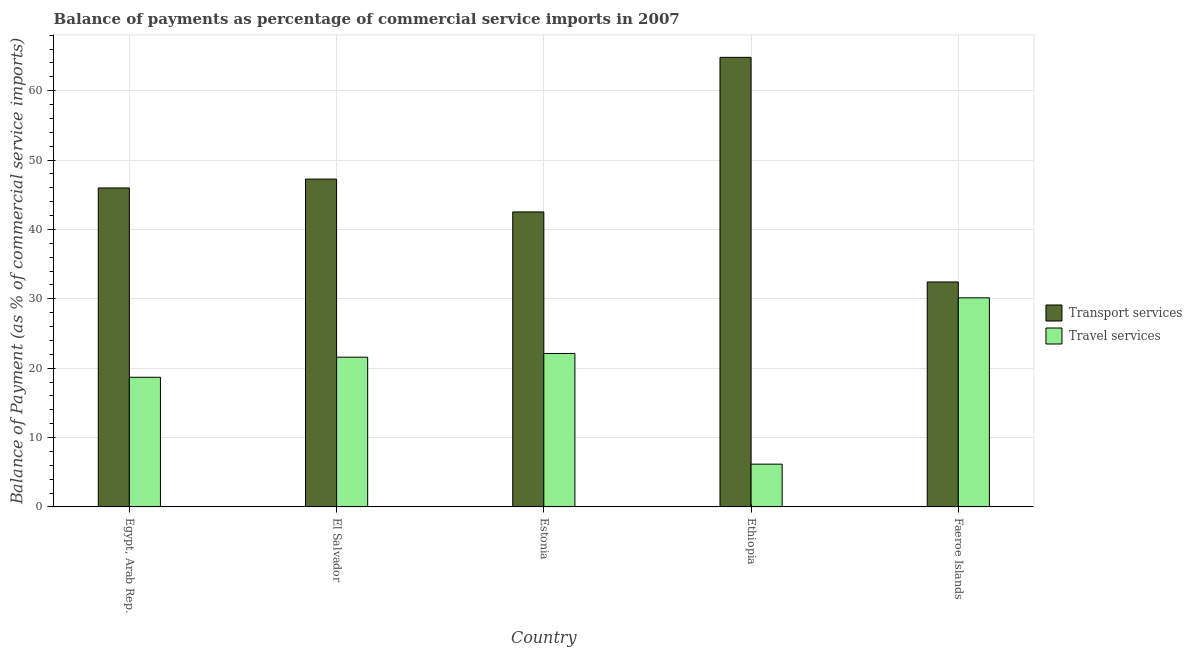Are the number of bars per tick equal to the number of legend labels?
Your response must be concise. Yes. Are the number of bars on each tick of the X-axis equal?
Give a very brief answer. Yes. How many bars are there on the 1st tick from the right?
Provide a short and direct response. 2. What is the label of the 1st group of bars from the left?
Your answer should be very brief. Egypt, Arab Rep. In how many cases, is the number of bars for a given country not equal to the number of legend labels?
Provide a short and direct response. 0. What is the balance of payments of travel services in Estonia?
Your answer should be very brief. 22.12. Across all countries, what is the maximum balance of payments of transport services?
Keep it short and to the point. 64.8. Across all countries, what is the minimum balance of payments of travel services?
Your response must be concise. 6.17. In which country was the balance of payments of travel services maximum?
Provide a succinct answer. Faeroe Islands. In which country was the balance of payments of transport services minimum?
Give a very brief answer. Faeroe Islands. What is the total balance of payments of travel services in the graph?
Provide a short and direct response. 98.7. What is the difference between the balance of payments of transport services in Egypt, Arab Rep. and that in Ethiopia?
Your answer should be very brief. -18.82. What is the difference between the balance of payments of travel services in Estonia and the balance of payments of transport services in Ethiopia?
Offer a terse response. -42.68. What is the average balance of payments of transport services per country?
Your response must be concise. 46.6. What is the difference between the balance of payments of transport services and balance of payments of travel services in Ethiopia?
Provide a short and direct response. 58.63. In how many countries, is the balance of payments of travel services greater than 16 %?
Give a very brief answer. 4. What is the ratio of the balance of payments of travel services in El Salvador to that in Ethiopia?
Offer a terse response. 3.5. What is the difference between the highest and the second highest balance of payments of transport services?
Keep it short and to the point. 17.55. What is the difference between the highest and the lowest balance of payments of travel services?
Your response must be concise. 23.97. In how many countries, is the balance of payments of travel services greater than the average balance of payments of travel services taken over all countries?
Provide a succinct answer. 3. Is the sum of the balance of payments of travel services in Egypt, Arab Rep. and El Salvador greater than the maximum balance of payments of transport services across all countries?
Provide a succinct answer. No. What does the 2nd bar from the left in Ethiopia represents?
Provide a succinct answer. Travel services. What does the 1st bar from the right in Ethiopia represents?
Your response must be concise. Travel services. How many countries are there in the graph?
Offer a very short reply. 5. What is the difference between two consecutive major ticks on the Y-axis?
Offer a terse response. 10. Are the values on the major ticks of Y-axis written in scientific E-notation?
Offer a terse response. No. Does the graph contain grids?
Make the answer very short. Yes. Where does the legend appear in the graph?
Make the answer very short. Center right. How many legend labels are there?
Offer a very short reply. 2. What is the title of the graph?
Offer a terse response. Balance of payments as percentage of commercial service imports in 2007. Does "Non-pregnant women" appear as one of the legend labels in the graph?
Your answer should be compact. No. What is the label or title of the Y-axis?
Your answer should be very brief. Balance of Payment (as % of commercial service imports). What is the Balance of Payment (as % of commercial service imports) of Transport services in Egypt, Arab Rep.?
Offer a terse response. 45.98. What is the Balance of Payment (as % of commercial service imports) of Travel services in Egypt, Arab Rep.?
Give a very brief answer. 18.69. What is the Balance of Payment (as % of commercial service imports) of Transport services in El Salvador?
Provide a short and direct response. 47.25. What is the Balance of Payment (as % of commercial service imports) in Travel services in El Salvador?
Give a very brief answer. 21.59. What is the Balance of Payment (as % of commercial service imports) of Transport services in Estonia?
Your answer should be very brief. 42.52. What is the Balance of Payment (as % of commercial service imports) of Travel services in Estonia?
Keep it short and to the point. 22.12. What is the Balance of Payment (as % of commercial service imports) of Transport services in Ethiopia?
Your answer should be very brief. 64.8. What is the Balance of Payment (as % of commercial service imports) in Travel services in Ethiopia?
Your answer should be compact. 6.17. What is the Balance of Payment (as % of commercial service imports) in Transport services in Faeroe Islands?
Provide a succinct answer. 32.43. What is the Balance of Payment (as % of commercial service imports) of Travel services in Faeroe Islands?
Offer a terse response. 30.14. Across all countries, what is the maximum Balance of Payment (as % of commercial service imports) in Transport services?
Offer a terse response. 64.8. Across all countries, what is the maximum Balance of Payment (as % of commercial service imports) of Travel services?
Offer a very short reply. 30.14. Across all countries, what is the minimum Balance of Payment (as % of commercial service imports) of Transport services?
Your answer should be compact. 32.43. Across all countries, what is the minimum Balance of Payment (as % of commercial service imports) in Travel services?
Your answer should be compact. 6.17. What is the total Balance of Payment (as % of commercial service imports) in Transport services in the graph?
Give a very brief answer. 232.98. What is the total Balance of Payment (as % of commercial service imports) of Travel services in the graph?
Offer a very short reply. 98.7. What is the difference between the Balance of Payment (as % of commercial service imports) of Transport services in Egypt, Arab Rep. and that in El Salvador?
Make the answer very short. -1.28. What is the difference between the Balance of Payment (as % of commercial service imports) of Travel services in Egypt, Arab Rep. and that in El Salvador?
Your response must be concise. -2.9. What is the difference between the Balance of Payment (as % of commercial service imports) of Transport services in Egypt, Arab Rep. and that in Estonia?
Make the answer very short. 3.46. What is the difference between the Balance of Payment (as % of commercial service imports) of Travel services in Egypt, Arab Rep. and that in Estonia?
Your response must be concise. -3.43. What is the difference between the Balance of Payment (as % of commercial service imports) in Transport services in Egypt, Arab Rep. and that in Ethiopia?
Provide a short and direct response. -18.82. What is the difference between the Balance of Payment (as % of commercial service imports) of Travel services in Egypt, Arab Rep. and that in Ethiopia?
Your response must be concise. 12.52. What is the difference between the Balance of Payment (as % of commercial service imports) of Transport services in Egypt, Arab Rep. and that in Faeroe Islands?
Your answer should be compact. 13.55. What is the difference between the Balance of Payment (as % of commercial service imports) of Travel services in Egypt, Arab Rep. and that in Faeroe Islands?
Your response must be concise. -11.45. What is the difference between the Balance of Payment (as % of commercial service imports) in Transport services in El Salvador and that in Estonia?
Offer a terse response. 4.73. What is the difference between the Balance of Payment (as % of commercial service imports) in Travel services in El Salvador and that in Estonia?
Provide a short and direct response. -0.53. What is the difference between the Balance of Payment (as % of commercial service imports) of Transport services in El Salvador and that in Ethiopia?
Your answer should be compact. -17.55. What is the difference between the Balance of Payment (as % of commercial service imports) of Travel services in El Salvador and that in Ethiopia?
Your answer should be very brief. 15.42. What is the difference between the Balance of Payment (as % of commercial service imports) in Transport services in El Salvador and that in Faeroe Islands?
Make the answer very short. 14.83. What is the difference between the Balance of Payment (as % of commercial service imports) of Travel services in El Salvador and that in Faeroe Islands?
Provide a short and direct response. -8.56. What is the difference between the Balance of Payment (as % of commercial service imports) of Transport services in Estonia and that in Ethiopia?
Your response must be concise. -22.28. What is the difference between the Balance of Payment (as % of commercial service imports) in Travel services in Estonia and that in Ethiopia?
Make the answer very short. 15.95. What is the difference between the Balance of Payment (as % of commercial service imports) of Transport services in Estonia and that in Faeroe Islands?
Ensure brevity in your answer.  10.09. What is the difference between the Balance of Payment (as % of commercial service imports) in Travel services in Estonia and that in Faeroe Islands?
Provide a short and direct response. -8.02. What is the difference between the Balance of Payment (as % of commercial service imports) of Transport services in Ethiopia and that in Faeroe Islands?
Your answer should be very brief. 32.38. What is the difference between the Balance of Payment (as % of commercial service imports) of Travel services in Ethiopia and that in Faeroe Islands?
Make the answer very short. -23.97. What is the difference between the Balance of Payment (as % of commercial service imports) of Transport services in Egypt, Arab Rep. and the Balance of Payment (as % of commercial service imports) of Travel services in El Salvador?
Give a very brief answer. 24.39. What is the difference between the Balance of Payment (as % of commercial service imports) in Transport services in Egypt, Arab Rep. and the Balance of Payment (as % of commercial service imports) in Travel services in Estonia?
Offer a very short reply. 23.86. What is the difference between the Balance of Payment (as % of commercial service imports) in Transport services in Egypt, Arab Rep. and the Balance of Payment (as % of commercial service imports) in Travel services in Ethiopia?
Your answer should be compact. 39.81. What is the difference between the Balance of Payment (as % of commercial service imports) of Transport services in Egypt, Arab Rep. and the Balance of Payment (as % of commercial service imports) of Travel services in Faeroe Islands?
Offer a terse response. 15.84. What is the difference between the Balance of Payment (as % of commercial service imports) in Transport services in El Salvador and the Balance of Payment (as % of commercial service imports) in Travel services in Estonia?
Offer a very short reply. 25.13. What is the difference between the Balance of Payment (as % of commercial service imports) in Transport services in El Salvador and the Balance of Payment (as % of commercial service imports) in Travel services in Ethiopia?
Provide a short and direct response. 41.09. What is the difference between the Balance of Payment (as % of commercial service imports) in Transport services in El Salvador and the Balance of Payment (as % of commercial service imports) in Travel services in Faeroe Islands?
Provide a short and direct response. 17.11. What is the difference between the Balance of Payment (as % of commercial service imports) in Transport services in Estonia and the Balance of Payment (as % of commercial service imports) in Travel services in Ethiopia?
Provide a short and direct response. 36.35. What is the difference between the Balance of Payment (as % of commercial service imports) in Transport services in Estonia and the Balance of Payment (as % of commercial service imports) in Travel services in Faeroe Islands?
Ensure brevity in your answer.  12.38. What is the difference between the Balance of Payment (as % of commercial service imports) in Transport services in Ethiopia and the Balance of Payment (as % of commercial service imports) in Travel services in Faeroe Islands?
Ensure brevity in your answer.  34.66. What is the average Balance of Payment (as % of commercial service imports) in Transport services per country?
Make the answer very short. 46.6. What is the average Balance of Payment (as % of commercial service imports) of Travel services per country?
Your response must be concise. 19.74. What is the difference between the Balance of Payment (as % of commercial service imports) of Transport services and Balance of Payment (as % of commercial service imports) of Travel services in Egypt, Arab Rep.?
Offer a very short reply. 27.29. What is the difference between the Balance of Payment (as % of commercial service imports) of Transport services and Balance of Payment (as % of commercial service imports) of Travel services in El Salvador?
Your response must be concise. 25.67. What is the difference between the Balance of Payment (as % of commercial service imports) in Transport services and Balance of Payment (as % of commercial service imports) in Travel services in Estonia?
Provide a succinct answer. 20.4. What is the difference between the Balance of Payment (as % of commercial service imports) in Transport services and Balance of Payment (as % of commercial service imports) in Travel services in Ethiopia?
Your response must be concise. 58.63. What is the difference between the Balance of Payment (as % of commercial service imports) of Transport services and Balance of Payment (as % of commercial service imports) of Travel services in Faeroe Islands?
Offer a very short reply. 2.29. What is the ratio of the Balance of Payment (as % of commercial service imports) of Travel services in Egypt, Arab Rep. to that in El Salvador?
Offer a very short reply. 0.87. What is the ratio of the Balance of Payment (as % of commercial service imports) in Transport services in Egypt, Arab Rep. to that in Estonia?
Ensure brevity in your answer.  1.08. What is the ratio of the Balance of Payment (as % of commercial service imports) in Travel services in Egypt, Arab Rep. to that in Estonia?
Offer a very short reply. 0.84. What is the ratio of the Balance of Payment (as % of commercial service imports) of Transport services in Egypt, Arab Rep. to that in Ethiopia?
Your answer should be very brief. 0.71. What is the ratio of the Balance of Payment (as % of commercial service imports) of Travel services in Egypt, Arab Rep. to that in Ethiopia?
Give a very brief answer. 3.03. What is the ratio of the Balance of Payment (as % of commercial service imports) of Transport services in Egypt, Arab Rep. to that in Faeroe Islands?
Offer a very short reply. 1.42. What is the ratio of the Balance of Payment (as % of commercial service imports) of Travel services in Egypt, Arab Rep. to that in Faeroe Islands?
Offer a terse response. 0.62. What is the ratio of the Balance of Payment (as % of commercial service imports) in Transport services in El Salvador to that in Estonia?
Keep it short and to the point. 1.11. What is the ratio of the Balance of Payment (as % of commercial service imports) of Travel services in El Salvador to that in Estonia?
Your answer should be compact. 0.98. What is the ratio of the Balance of Payment (as % of commercial service imports) of Transport services in El Salvador to that in Ethiopia?
Provide a short and direct response. 0.73. What is the ratio of the Balance of Payment (as % of commercial service imports) of Travel services in El Salvador to that in Ethiopia?
Provide a short and direct response. 3.5. What is the ratio of the Balance of Payment (as % of commercial service imports) in Transport services in El Salvador to that in Faeroe Islands?
Offer a terse response. 1.46. What is the ratio of the Balance of Payment (as % of commercial service imports) in Travel services in El Salvador to that in Faeroe Islands?
Ensure brevity in your answer.  0.72. What is the ratio of the Balance of Payment (as % of commercial service imports) in Transport services in Estonia to that in Ethiopia?
Make the answer very short. 0.66. What is the ratio of the Balance of Payment (as % of commercial service imports) of Travel services in Estonia to that in Ethiopia?
Offer a terse response. 3.59. What is the ratio of the Balance of Payment (as % of commercial service imports) in Transport services in Estonia to that in Faeroe Islands?
Provide a succinct answer. 1.31. What is the ratio of the Balance of Payment (as % of commercial service imports) of Travel services in Estonia to that in Faeroe Islands?
Provide a succinct answer. 0.73. What is the ratio of the Balance of Payment (as % of commercial service imports) in Transport services in Ethiopia to that in Faeroe Islands?
Your response must be concise. 2. What is the ratio of the Balance of Payment (as % of commercial service imports) in Travel services in Ethiopia to that in Faeroe Islands?
Your answer should be very brief. 0.2. What is the difference between the highest and the second highest Balance of Payment (as % of commercial service imports) of Transport services?
Your answer should be very brief. 17.55. What is the difference between the highest and the second highest Balance of Payment (as % of commercial service imports) of Travel services?
Provide a succinct answer. 8.02. What is the difference between the highest and the lowest Balance of Payment (as % of commercial service imports) of Transport services?
Your answer should be compact. 32.38. What is the difference between the highest and the lowest Balance of Payment (as % of commercial service imports) of Travel services?
Keep it short and to the point. 23.97. 